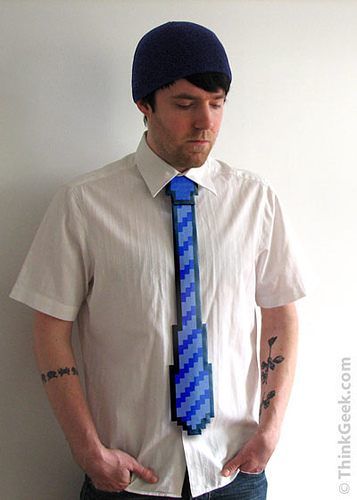Read and extract the text from this image. ThinkGeek.com 